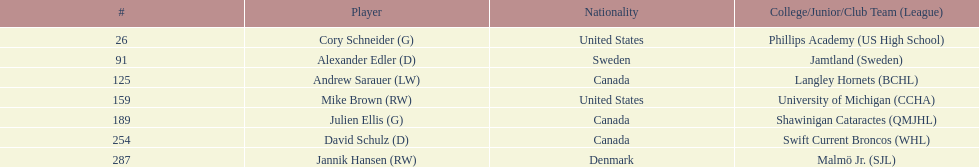What is the number of players originating from the united states? 2. 